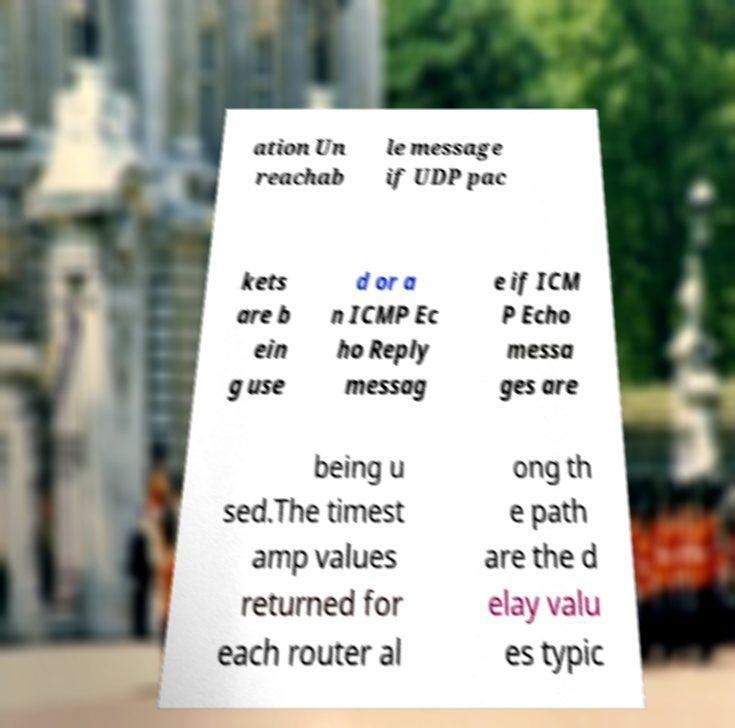I need the written content from this picture converted into text. Can you do that? ation Un reachab le message if UDP pac kets are b ein g use d or a n ICMP Ec ho Reply messag e if ICM P Echo messa ges are being u sed.The timest amp values returned for each router al ong th e path are the d elay valu es typic 